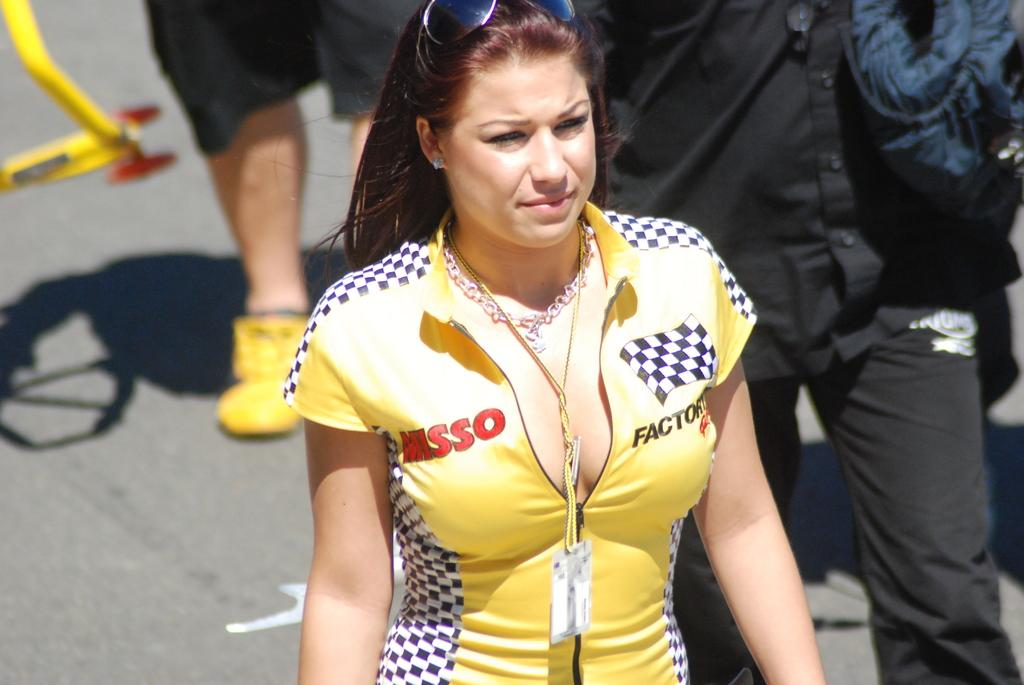<image>
Describe the image concisely. A woman with a yellow racing outfit with Misso on the front is walking. 